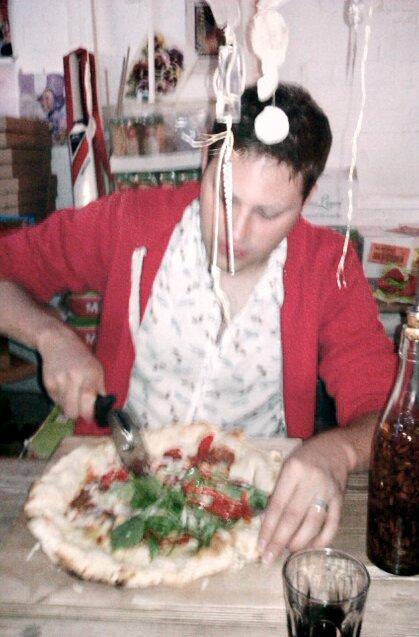Is the person wearing a ring?
Be succinct. Yes. What does the man hold in his right hand?
Be succinct. Pizza cutter. How many slices is she cutting?
Write a very short answer. 8. What are they eating?
Concise answer only. Pizza. 